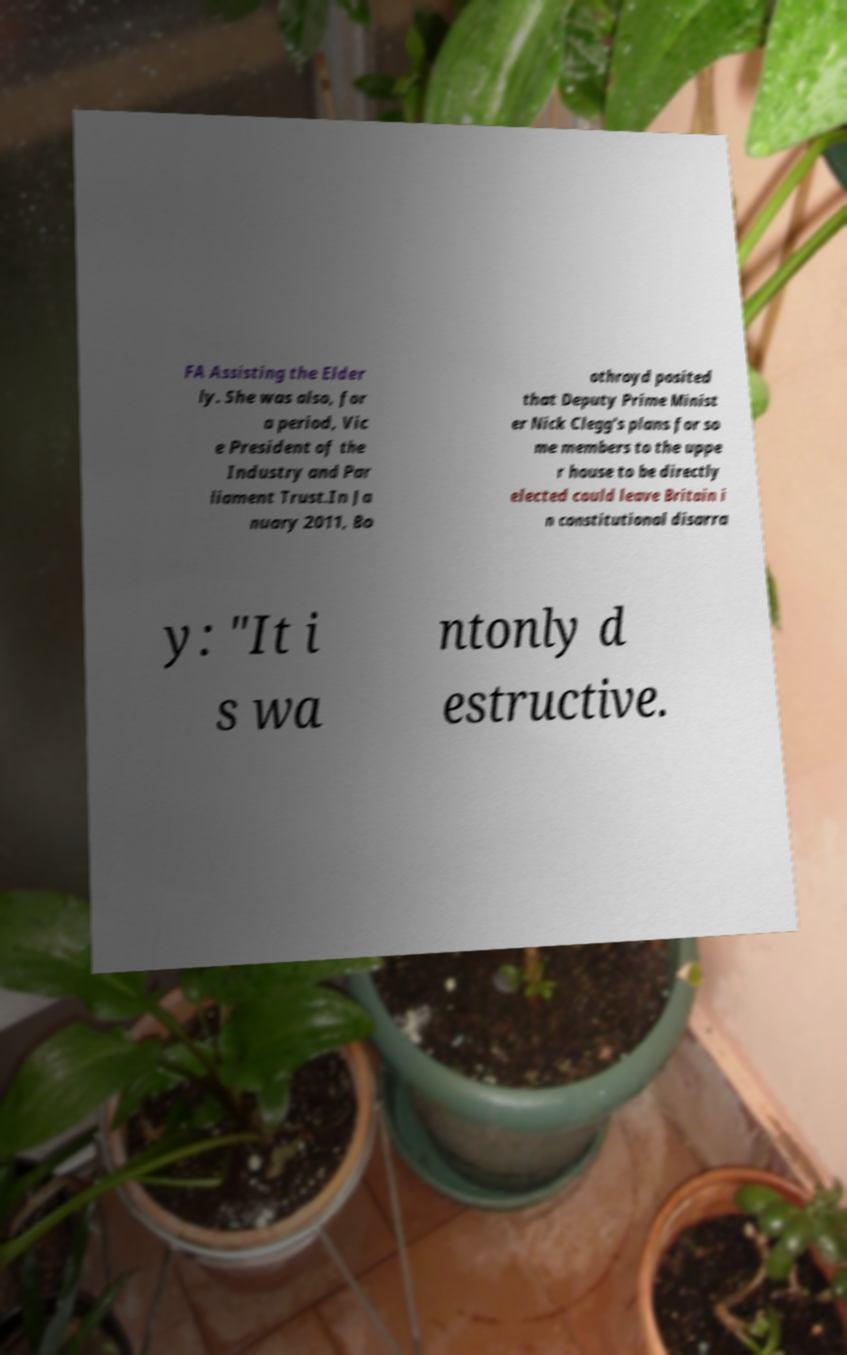What messages or text are displayed in this image? I need them in a readable, typed format. FA Assisting the Elder ly. She was also, for a period, Vic e President of the Industry and Par liament Trust.In Ja nuary 2011, Bo othroyd posited that Deputy Prime Minist er Nick Clegg's plans for so me members to the uppe r house to be directly elected could leave Britain i n constitutional disarra y: "It i s wa ntonly d estructive. 